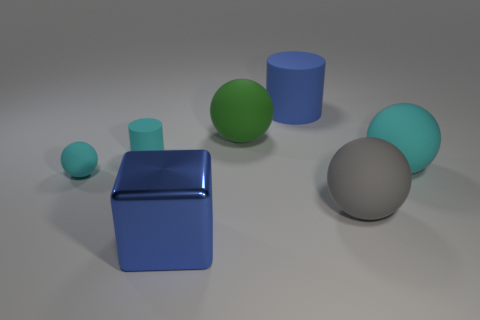How many cyan balls must be subtracted to get 1 cyan balls? 1 Subtract all brown blocks. How many cyan balls are left? 2 Subtract all large cyan spheres. How many spheres are left? 3 Add 1 brown cubes. How many objects exist? 8 Subtract all gray balls. How many balls are left? 3 Subtract all spheres. How many objects are left? 3 Subtract 1 green spheres. How many objects are left? 6 Subtract all cyan cubes. Subtract all cyan balls. How many cubes are left? 1 Subtract all small metal cylinders. Subtract all small cylinders. How many objects are left? 6 Add 4 blocks. How many blocks are left? 5 